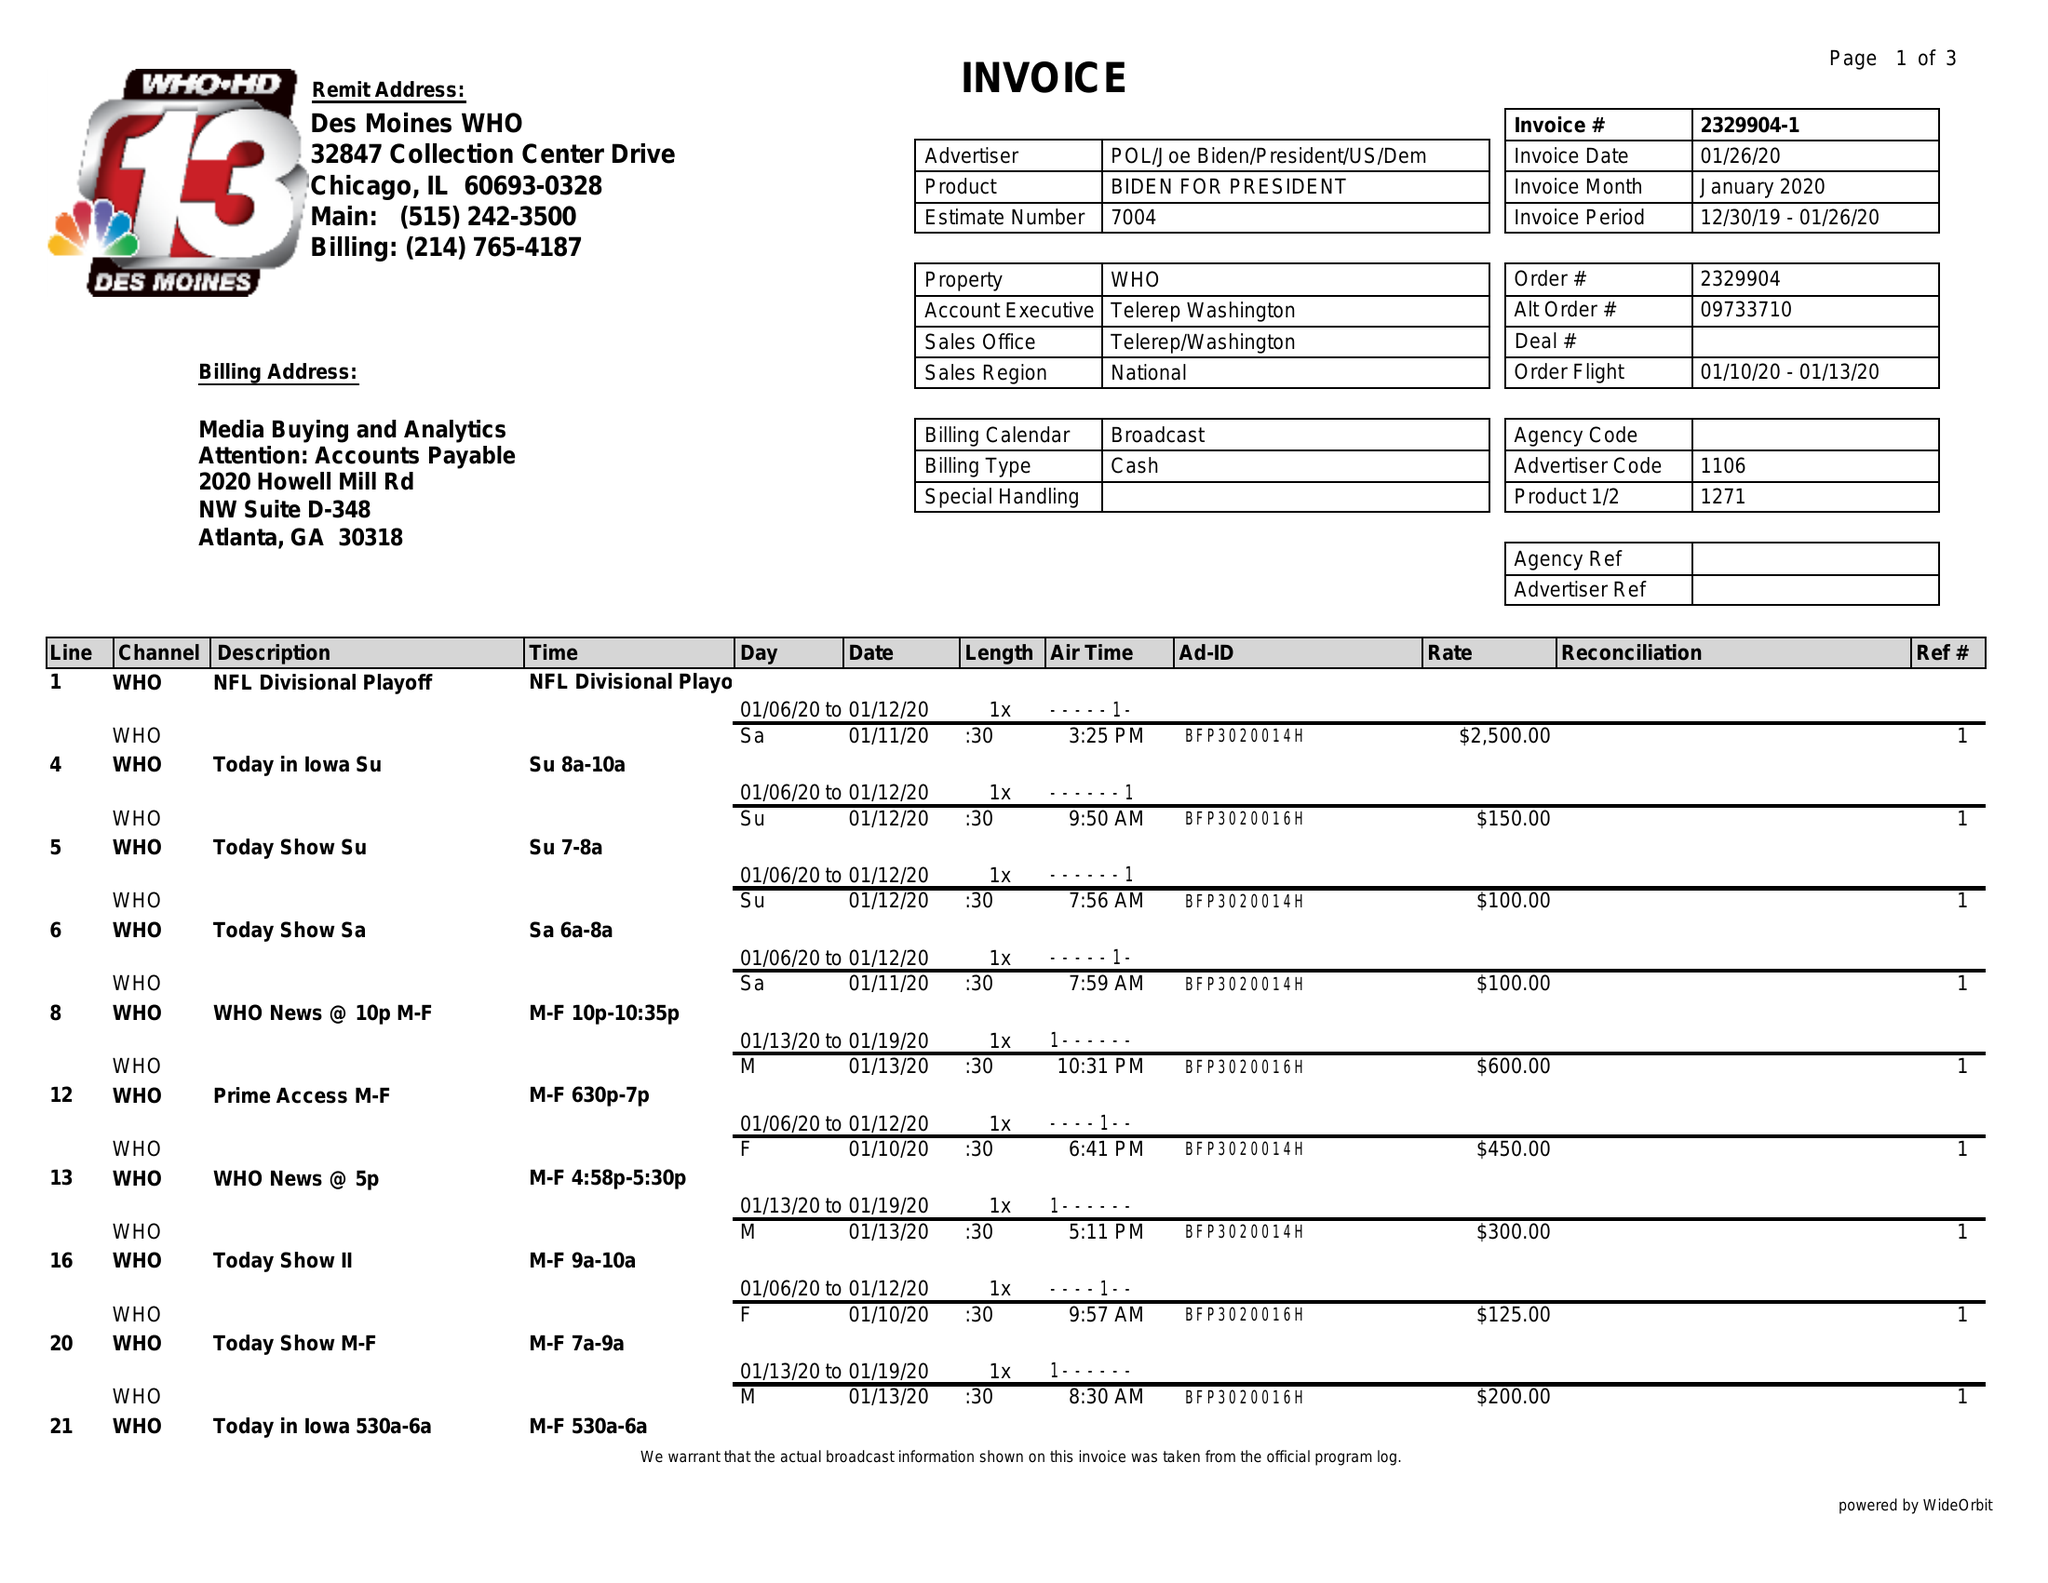What is the value for the flight_from?
Answer the question using a single word or phrase. 01/10/20 